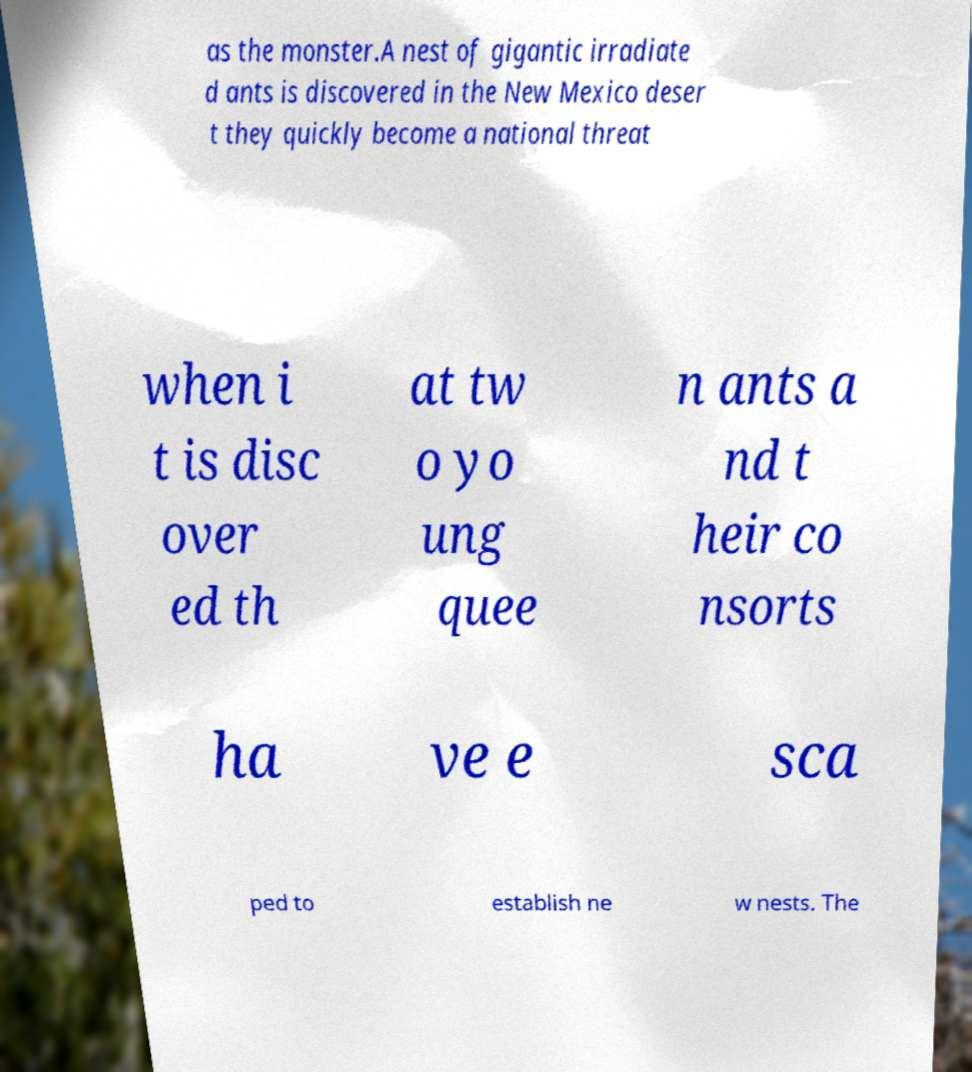Could you extract and type out the text from this image? as the monster.A nest of gigantic irradiate d ants is discovered in the New Mexico deser t they quickly become a national threat when i t is disc over ed th at tw o yo ung quee n ants a nd t heir co nsorts ha ve e sca ped to establish ne w nests. The 